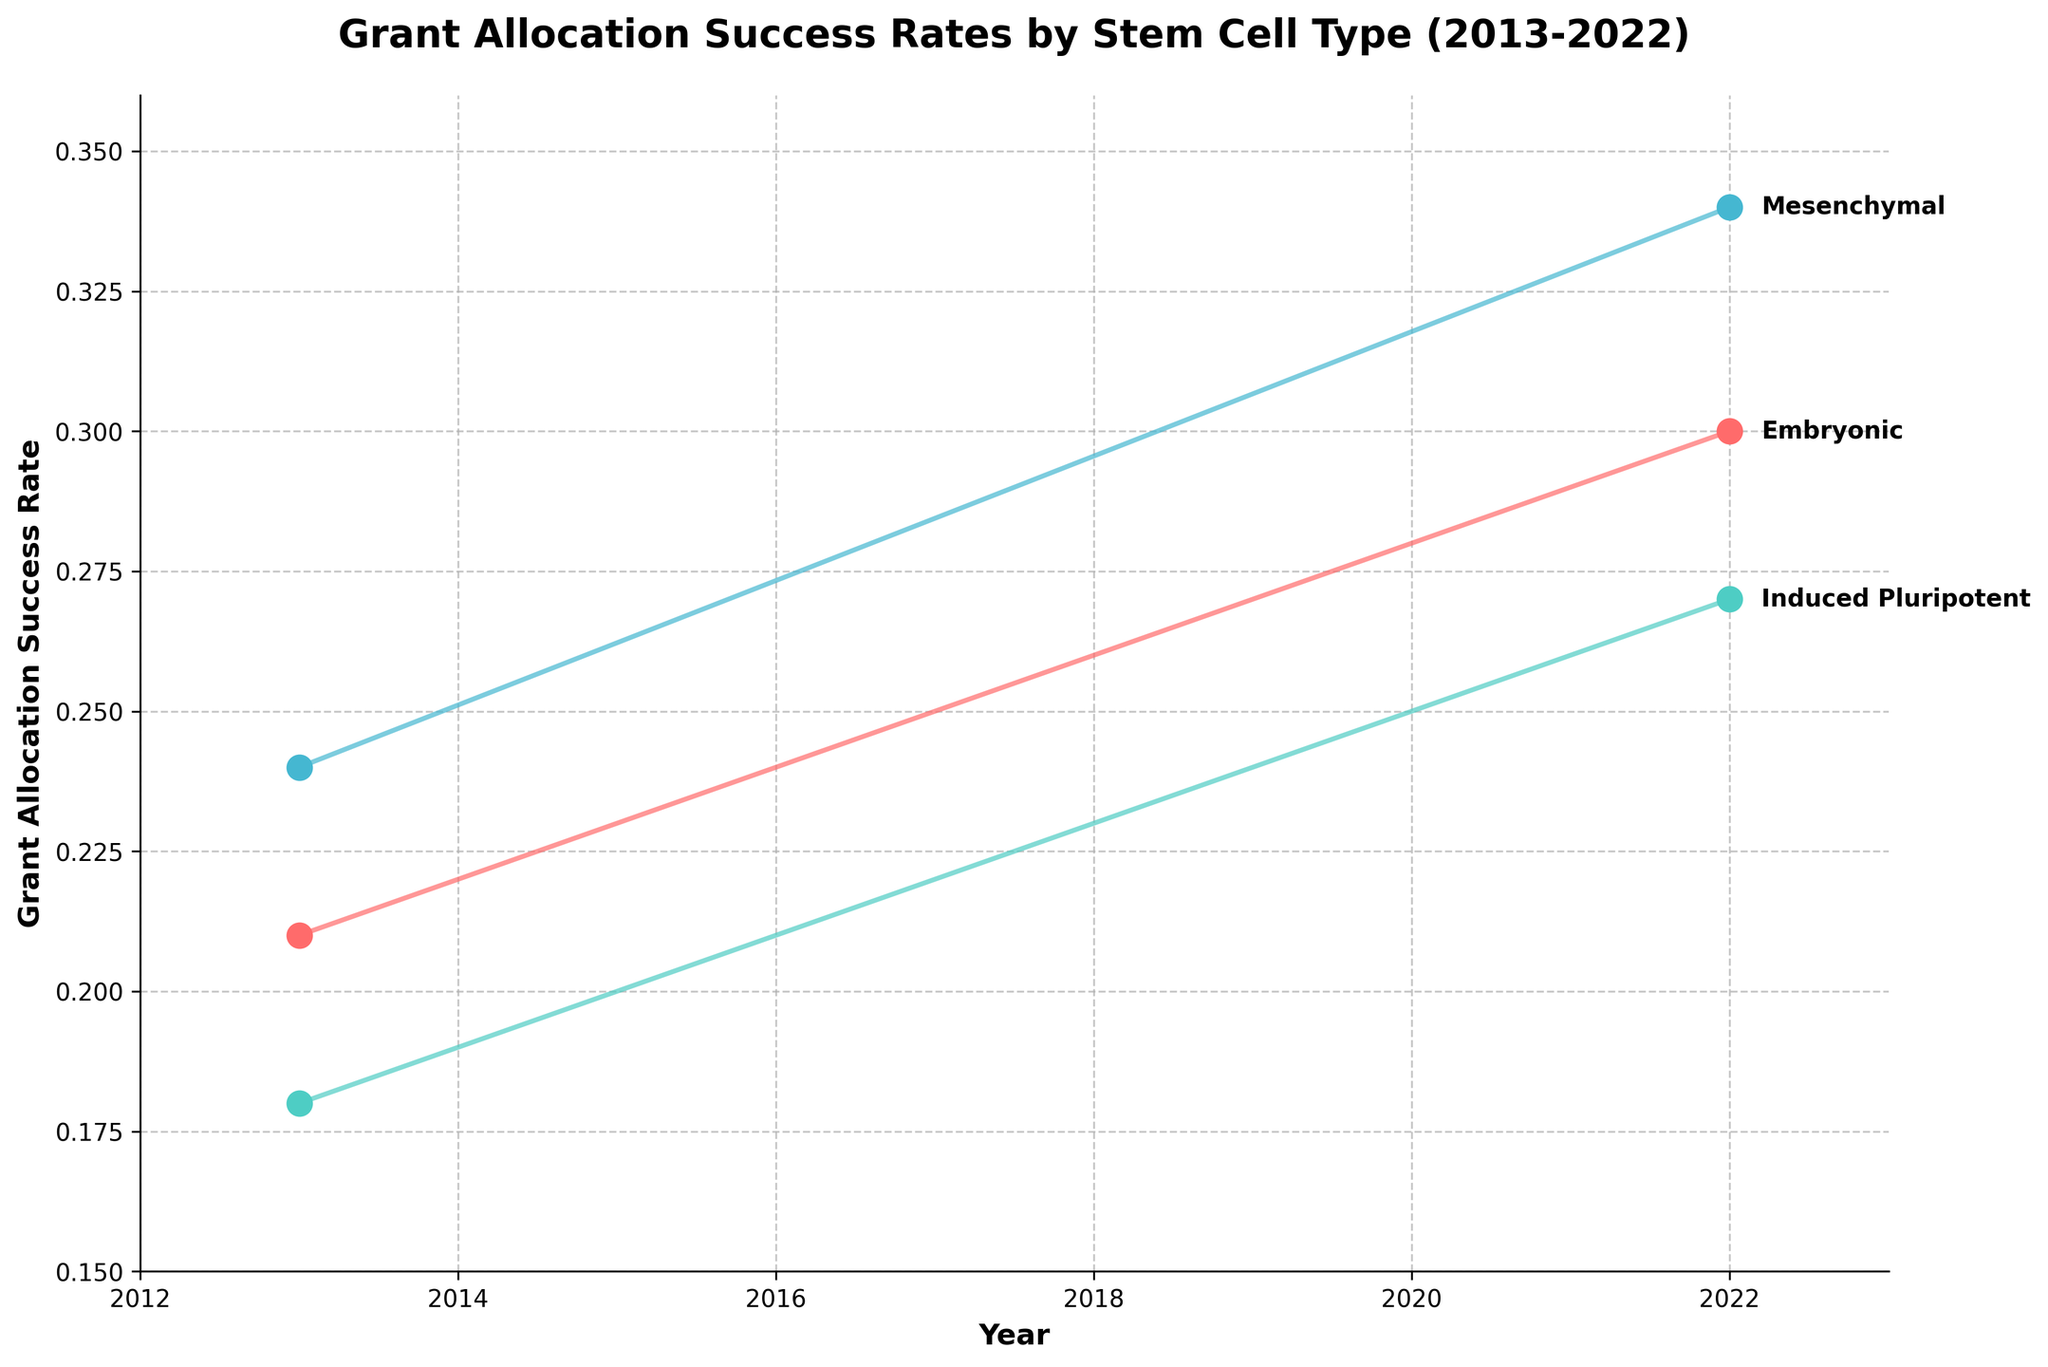What is the title of the figure? The title is typically found at the top of the plot and provides a succinct description of what the plot represents. The title in this figure is positioned prominently and in bold text.
Answer: Grant Allocation Success Rates by Stem Cell Type (2013-2022) What are the years covered in the figure? The x-axis of the plot represents the timeline. The earliest year on the x-axis is 2013, and the latest year is 2022.
Answer: 2013-2022 What stem cell type has the highest grant allocation success rate in 2022? To find the highest success rate, we look at the endpoints of the lines in 2022 (right side of the plot). The Mesenchymal stem cell type has the top position.
Answer: Mesenchymal What is the trend observed in the grant allocation success rate for Induced Pluripotent stem cells from 2013 to 2022? Follow the line corresponding to Induced Pluripotent stem cells from the left end (2013) to the right end (2022). The trend shows an increase in the success rate over the years.
Answer: Increasing Which stem cell type had the lowest success rate in 2013? Look at the starting points of the lines corresponding to each stem cell type in 2013 (left side of the plot). The Induced Pluripotent stem cell type is at the bottom.
Answer: Induced Pluripotent How much did the grant allocation success rate for Embryonic stem cells change between 2013 and 2022? Find the success rate for Embryonic stem cells in 2013 and 2022 on the y-axis, and calculate the difference: 0.30 (2022) - 0.21 (2013) = 0.09.
Answer: 0.09 What general pattern do you observe in the success rates for all stem cell types from 2013 to 2022? Examine the plot as a whole. All lines trend upward from 2013 to 2022, indicating an increase in success rates for all stem cell types.
Answer: Increasing Which stem cell type shows the most significant increase in success rate from 2013 to 2022? Compare the differences in success rates from 2013 to 2022 for each stem cell type. Mesenchymal stem cells have the highest change: 0.34 (2022) - 0.24 (2013) = 0.10.
Answer: Mesenchymal On average, what is the grant allocation success rate for Mesenchymal stem cells over the decade? Calculate the average by summing the success rates for Mesenchymal stem cells and dividing by the number of years: (0.24 + 0.25 + 0.26 + 0.27 + 0.28 + 0.29 + 0.30 + 0.31 + 0.32 + 0.34) / 10.
Answer: 0.286 